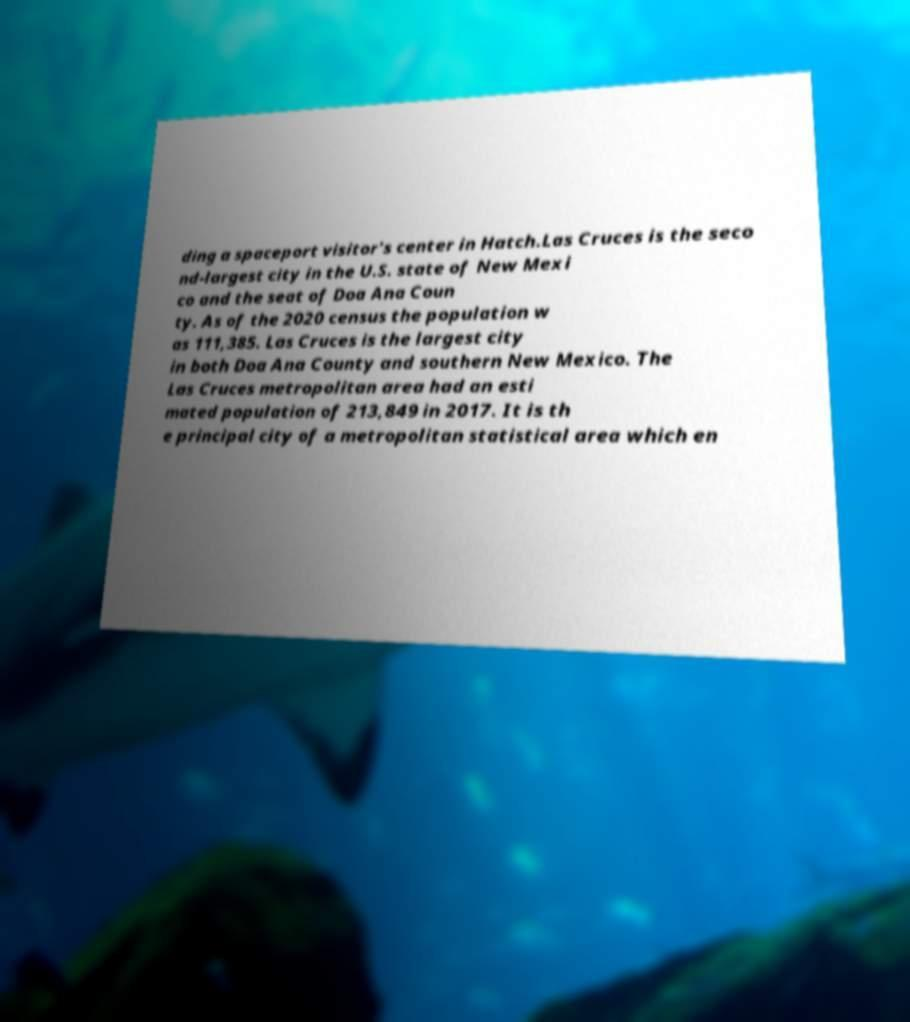There's text embedded in this image that I need extracted. Can you transcribe it verbatim? ding a spaceport visitor's center in Hatch.Las Cruces is the seco nd-largest city in the U.S. state of New Mexi co and the seat of Doa Ana Coun ty. As of the 2020 census the population w as 111,385. Las Cruces is the largest city in both Doa Ana County and southern New Mexico. The Las Cruces metropolitan area had an esti mated population of 213,849 in 2017. It is th e principal city of a metropolitan statistical area which en 